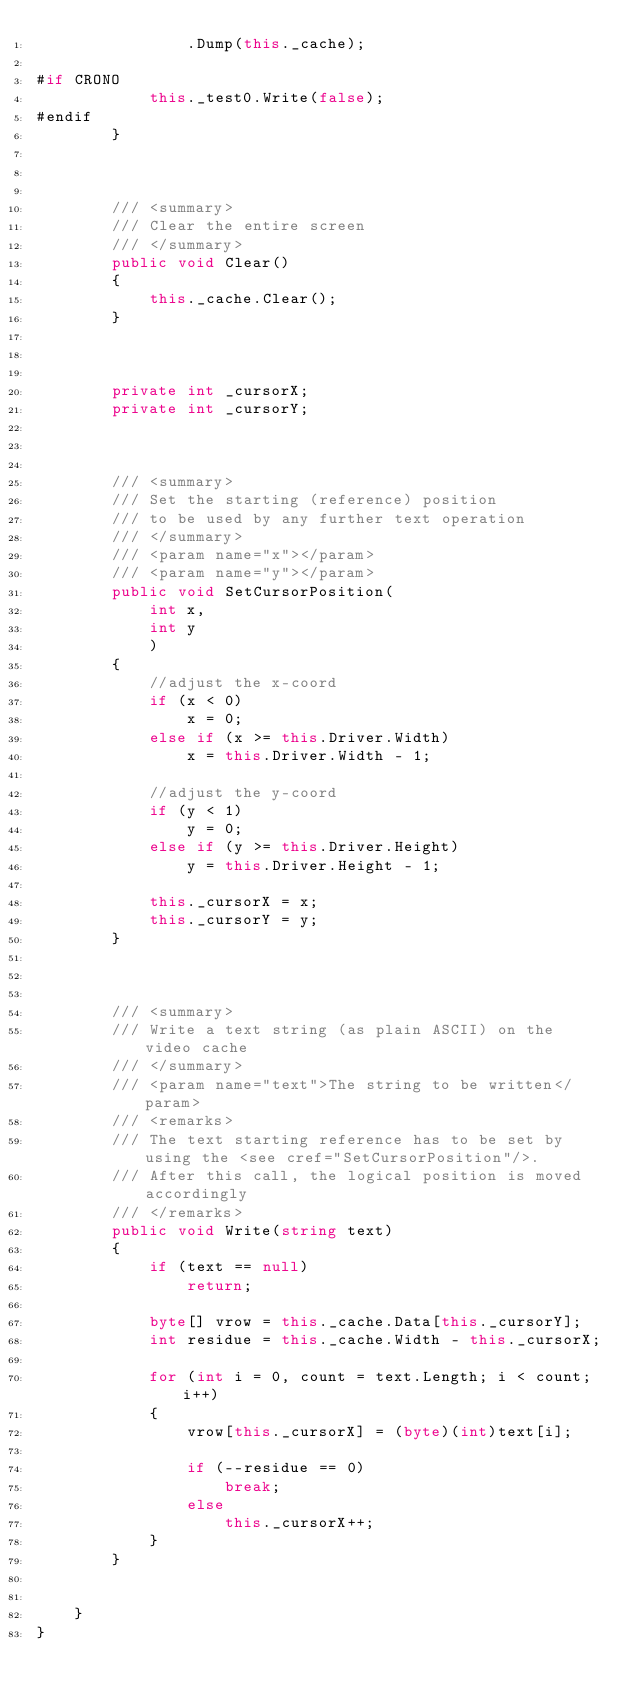Convert code to text. <code><loc_0><loc_0><loc_500><loc_500><_C#_>                .Dump(this._cache);

#if CRONO
            this._test0.Write(false);
#endif
        }



        /// <summary>
        /// Clear the entire screen
        /// </summary>
        public void Clear()
        {
            this._cache.Clear();
        }



        private int _cursorX;
        private int _cursorY;



        /// <summary>
        /// Set the starting (reference) position
        /// to be used by any further text operation
        /// </summary>
        /// <param name="x"></param>
        /// <param name="y"></param>
        public void SetCursorPosition(
            int x,
            int y
            )
        {
            //adjust the x-coord
            if (x < 0)
                x = 0;
            else if (x >= this.Driver.Width)
                x = this.Driver.Width - 1;

            //adjust the y-coord
            if (y < 1)
                y = 0;
            else if (y >= this.Driver.Height)
                y = this.Driver.Height - 1;

            this._cursorX = x;
            this._cursorY = y;
        }



        /// <summary>
        /// Write a text string (as plain ASCII) on the video cache
        /// </summary>
        /// <param name="text">The string to be written</param>
        /// <remarks>
        /// The text starting reference has to be set by using the <see cref="SetCursorPosition"/>.
        /// After this call, the logical position is moved accordingly
        /// </remarks>
        public void Write(string text)
        {
            if (text == null)
                return;

            byte[] vrow = this._cache.Data[this._cursorY];
            int residue = this._cache.Width - this._cursorX;

            for (int i = 0, count = text.Length; i < count; i++)
            {
                vrow[this._cursorX] = (byte)(int)text[i];

                if (--residue == 0)
                    break;
                else
                    this._cursorX++;
            }
        }


    }
}
</code> 